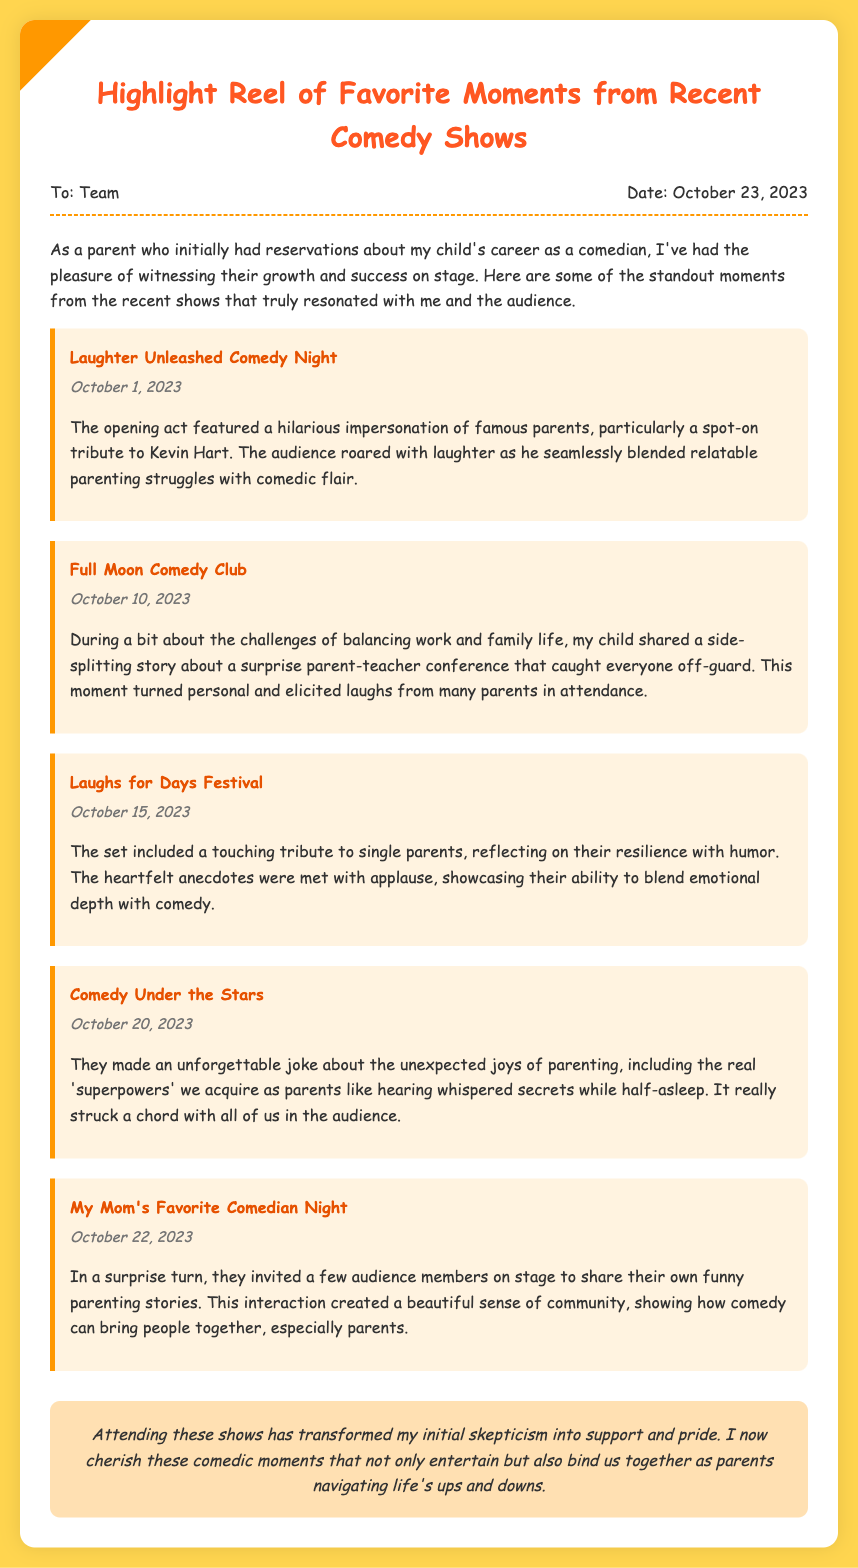What is the title of the memo? The title of the memo is provided at the top of the document.
Answer: Highlight Reel of Favorite Moments from Recent Comedy Shows When was the memo dated? The date of the memo is mentioned in the header section.
Answer: October 23, 2023 What was the event on October 1, 2023? The event title for this date is listed in the memo.
Answer: Laughter Unleashed Comedy Night Which event included a tribute to single parents? The memo mentions several events, and this tribute is specified.
Answer: Laughs for Days Festival What theme did the comedy act on October 20, 2023 focus on? The memo describes the theme of the comedy act for this event.
Answer: Unexpected joys of parenting How did the audience react to the surprise turn on October 22, 2023? The memo reflects on the audience's reaction to a specific interaction.
Answer: A beautiful sense of community Why did the author initially disapprove of the comedian's career? The memo starts with the author's initial feelings toward the career choice.
Answer: Reservations What emotion did the author express regarding attending the shows? The author describes their emotional transformation throughout the memo.
Answer: Pride What was the setting for the event on October 15, 2023? The setting type for this event is detailed within the discussions.
Answer: Festival 